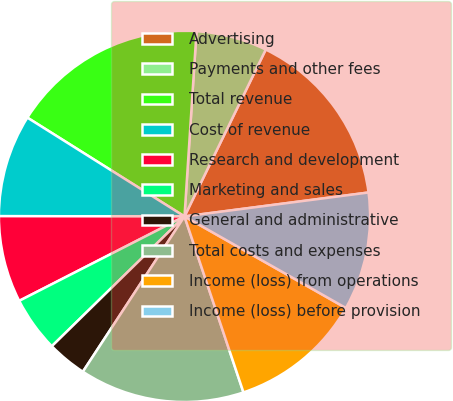Convert chart to OTSL. <chart><loc_0><loc_0><loc_500><loc_500><pie_chart><fcel>Advertising<fcel>Payments and other fees<fcel>Total revenue<fcel>Cost of revenue<fcel>Research and development<fcel>Marketing and sales<fcel>General and administrative<fcel>Total costs and expenses<fcel>Income (loss) from operations<fcel>Income (loss) before provision<nl><fcel>15.73%<fcel>6.18%<fcel>17.1%<fcel>8.91%<fcel>7.54%<fcel>4.81%<fcel>3.45%<fcel>14.37%<fcel>11.64%<fcel>10.27%<nl></chart> 